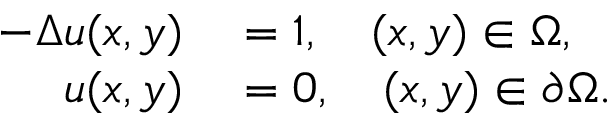<formula> <loc_0><loc_0><loc_500><loc_500>\begin{array} { r l } { - \Delta u ( x , y ) } & = 1 , \quad ( x , y ) \in \Omega , } \\ { u ( x , y ) } & = 0 , \quad ( x , y ) \in \partial \Omega . } \end{array}</formula> 